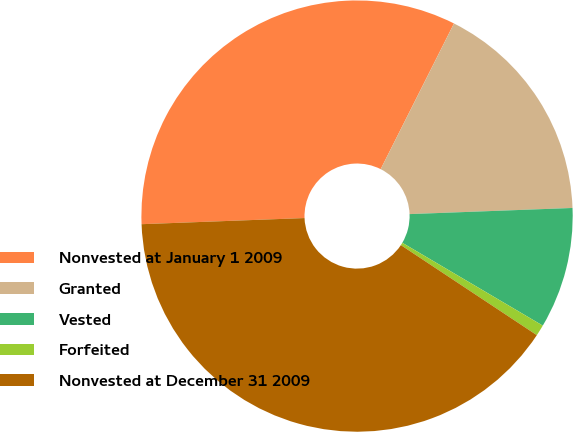Convert chart. <chart><loc_0><loc_0><loc_500><loc_500><pie_chart><fcel>Nonvested at January 1 2009<fcel>Granted<fcel>Vested<fcel>Forfeited<fcel>Nonvested at December 31 2009<nl><fcel>33.02%<fcel>16.98%<fcel>9.08%<fcel>0.83%<fcel>40.09%<nl></chart> 